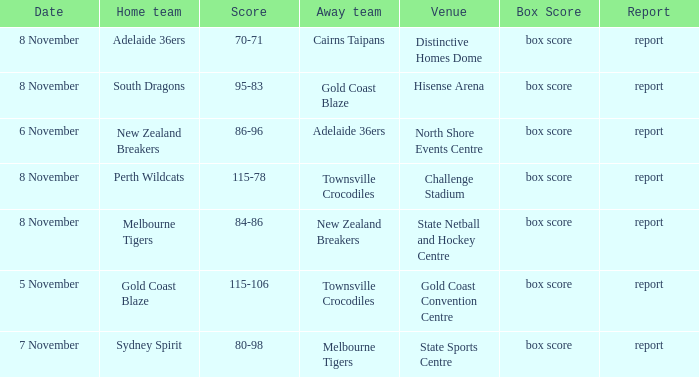What was the box score during a home game of the Adelaide 36ers? Box score. 